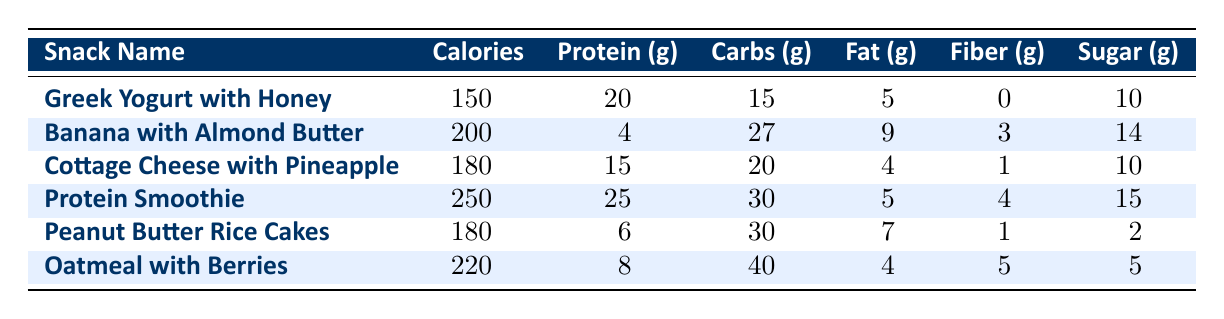What is the calorie count of Greek Yogurt with Honey? The calorie count for Greek Yogurt with Honey is directly listed in the table under the 'Calories' column. The value is 150.
Answer: 150 Which snack has the highest protein content? To determine which snack has the highest protein content, we need to compare the protein values in the 'Protein (g)' column. The highest value is 25 grams for the Protein Smoothie.
Answer: Protein Smoothie How many grams of carbohydrates are in Banana with Almond Butter? The number of grams of carbohydrates for Banana with Almond Butter is directly available in the table in the 'Carbs (g)' column, which states 27 grams.
Answer: 27 Is the fat content of Oatmeal with Berries less than that of Greek Yogurt with Honey? To answer this question, we compare the fat values of the two snacks. Oatmeal with Berries has 4 grams of fat, while Greek Yogurt with Honey has 5 grams. Since 4 is less than 5, the statement is true.
Answer: Yes What is the average sugar content of all snacks listed? To find the average sugar content, we first sum the sugar values from the 'Sugar (g)' column: 10 + 14 + 10 + 15 + 2 + 5 = 56. There are 6 snacks, so we divide the total by 6: 56 / 6 = 9.33.
Answer: 9.33 Which snack has the lowest calorie count and how many grams of sugar does it contain? The snack with the lowest calorie count is Greek Yogurt with Honey, with 150 calories. We then check the sugar content in the same row, which is 10 grams.
Answer: 10 Are there any snacks with more than 30 grams of carbohydrates? We can check the values in the 'Carbs (g)' column to see if any exceed 30 grams. The snacks with more than 30 grams are Peanut Butter Rice Cakes (30) and Oatmeal with Berries (40). Since at least one snack meets this criterion, the answer is yes.
Answer: Yes What is the total protein content when combining the Protein Smoothie and Peanut Butter Rice Cakes? We find the protein values for both snacks in the 'Protein (g)' column: Protein Smoothie contains 25 grams and Peanut Butter Rice Cakes contains 6 grams. Adding these gives 25 + 6 = 31 grams of protein total.
Answer: 31 